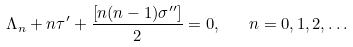<formula> <loc_0><loc_0><loc_500><loc_500>\Lambda _ { n } + n \tau ^ { \prime } + \frac { \left [ n ( n - 1 ) \sigma ^ { \prime \prime } \right ] } { 2 } = 0 , \quad n = 0 , 1 , 2 , \dots</formula> 